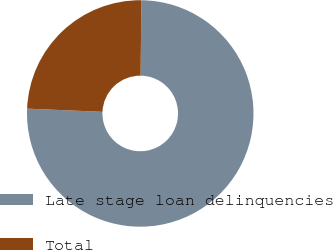Convert chart to OTSL. <chart><loc_0><loc_0><loc_500><loc_500><pie_chart><fcel>Late stage loan delinquencies<fcel>Total<nl><fcel>75.52%<fcel>24.48%<nl></chart> 